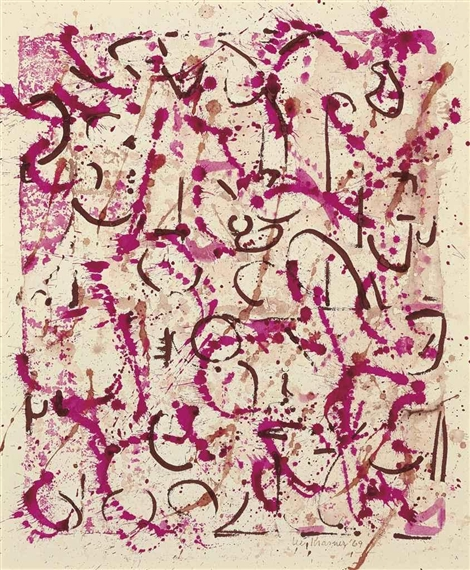Could this artwork be representing a narrative or story? If so, what might it be? While the artwork is abstract and doesn't depict a clear narrative or story, it can still be interpreted as telling a form of visual tale. The chaotic yet deliberate arrangement of lines and splatters could represent a journey or an emotional experience. One might imagine it depicting the tumultuous path of human emotions, with the vibrant pink possibly symbolizing love, passion, or conflict, and the black representing obstacles, struggles, or perhaps clarity brought about by introspection. Each viewer might uncover a unique story based on their own life experiences and emotional state. Do you think the colors used in this painting have specific symbolic meanings? Absolutely, colors often carry symbolic meanings and can elicit varied responses from viewers. In this painting, the use of bright pink could symbolize energy, vibrancy, love, or creativity. The black lines might signify depth, mystery, strength, or boundaries. Combined, they create stark contrasts that might represent the balance or clash between different emotional states or life's dualities. The interaction between these colors adds to the work's dynamic and possibly suggestive nature, allowing for rich interpretative depth. Imagine this artwork is a scene from a dream. What kind of dream would it be? This artwork could represent a vivid and surreal dream, where the boundaries of reality are blurred and emotions are heightened. In this dream, you might find yourself floating in an expansive white space where vibrant pink and black lines swirl around you like wisps of energy. The dream feels liberating yet slightly disorienting, filled with moments of clarity interspersed with confusion. It’s a journey inside your own mind, where subconscious thoughts and feelings surface, morphing into abstract forms before your eyes. The dream is both exhilarating and introspective, leaving a lasting impression of having touched something profound and mysterious. 